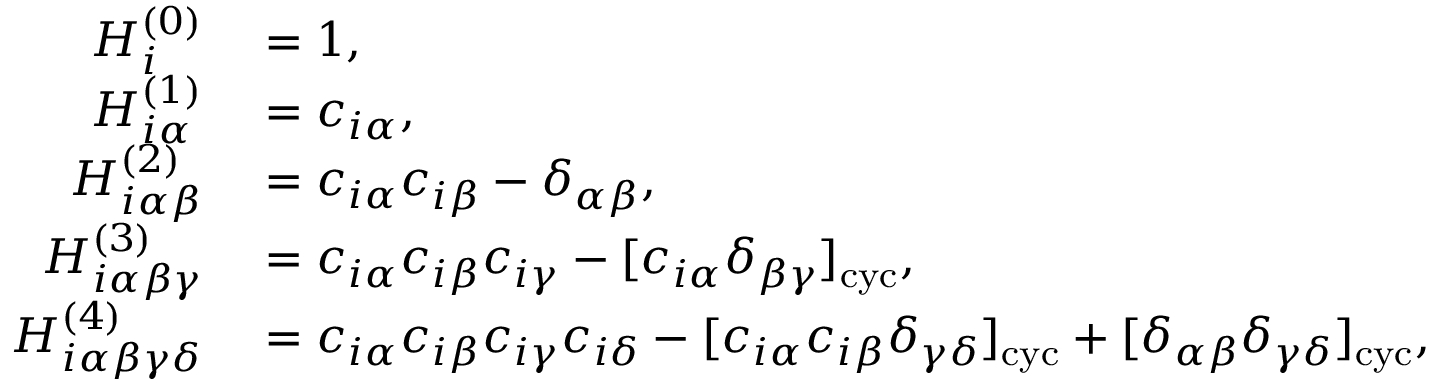<formula> <loc_0><loc_0><loc_500><loc_500>\begin{array} { r l } { H _ { i } ^ { ( 0 ) } } & = 1 , } \\ { H _ { i \alpha } ^ { ( 1 ) } } & = c _ { i \alpha } , } \\ { H _ { i \alpha \beta } ^ { ( 2 ) } } & = c _ { i \alpha } c _ { i \beta } - \delta _ { \alpha \beta } , } \\ { H _ { i \alpha \beta \gamma } ^ { ( 3 ) } } & = c _ { i \alpha } c _ { i \beta } c _ { i \gamma } - [ c _ { i \alpha } \delta _ { \beta \gamma } ] _ { c y c } , } \\ { H _ { i \alpha \beta \gamma \delta } ^ { ( 4 ) } } & = c _ { i \alpha } c _ { i \beta } c _ { i \gamma } c _ { i \delta } - [ c _ { i \alpha } c _ { i \beta } \delta _ { \gamma \delta } ] _ { c y c } + [ \delta _ { \alpha \beta } \delta _ { \gamma \delta } ] _ { c y c } , } \end{array}</formula> 